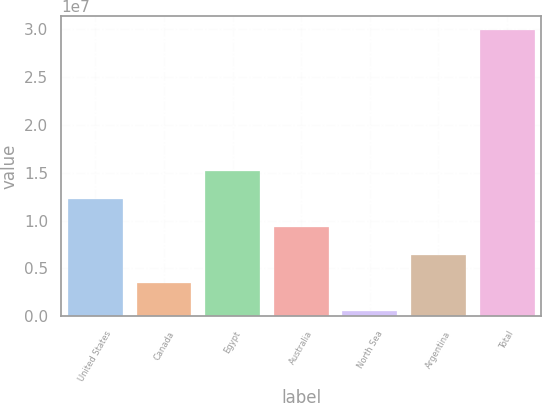Convert chart to OTSL. <chart><loc_0><loc_0><loc_500><loc_500><bar_chart><fcel>United States<fcel>Canada<fcel>Egypt<fcel>Australia<fcel>North Sea<fcel>Argentina<fcel>Total<nl><fcel>1.22758e+07<fcel>3.49129e+06<fcel>1.52039e+07<fcel>9.34761e+06<fcel>563129<fcel>6.41945e+06<fcel>2.98447e+07<nl></chart> 